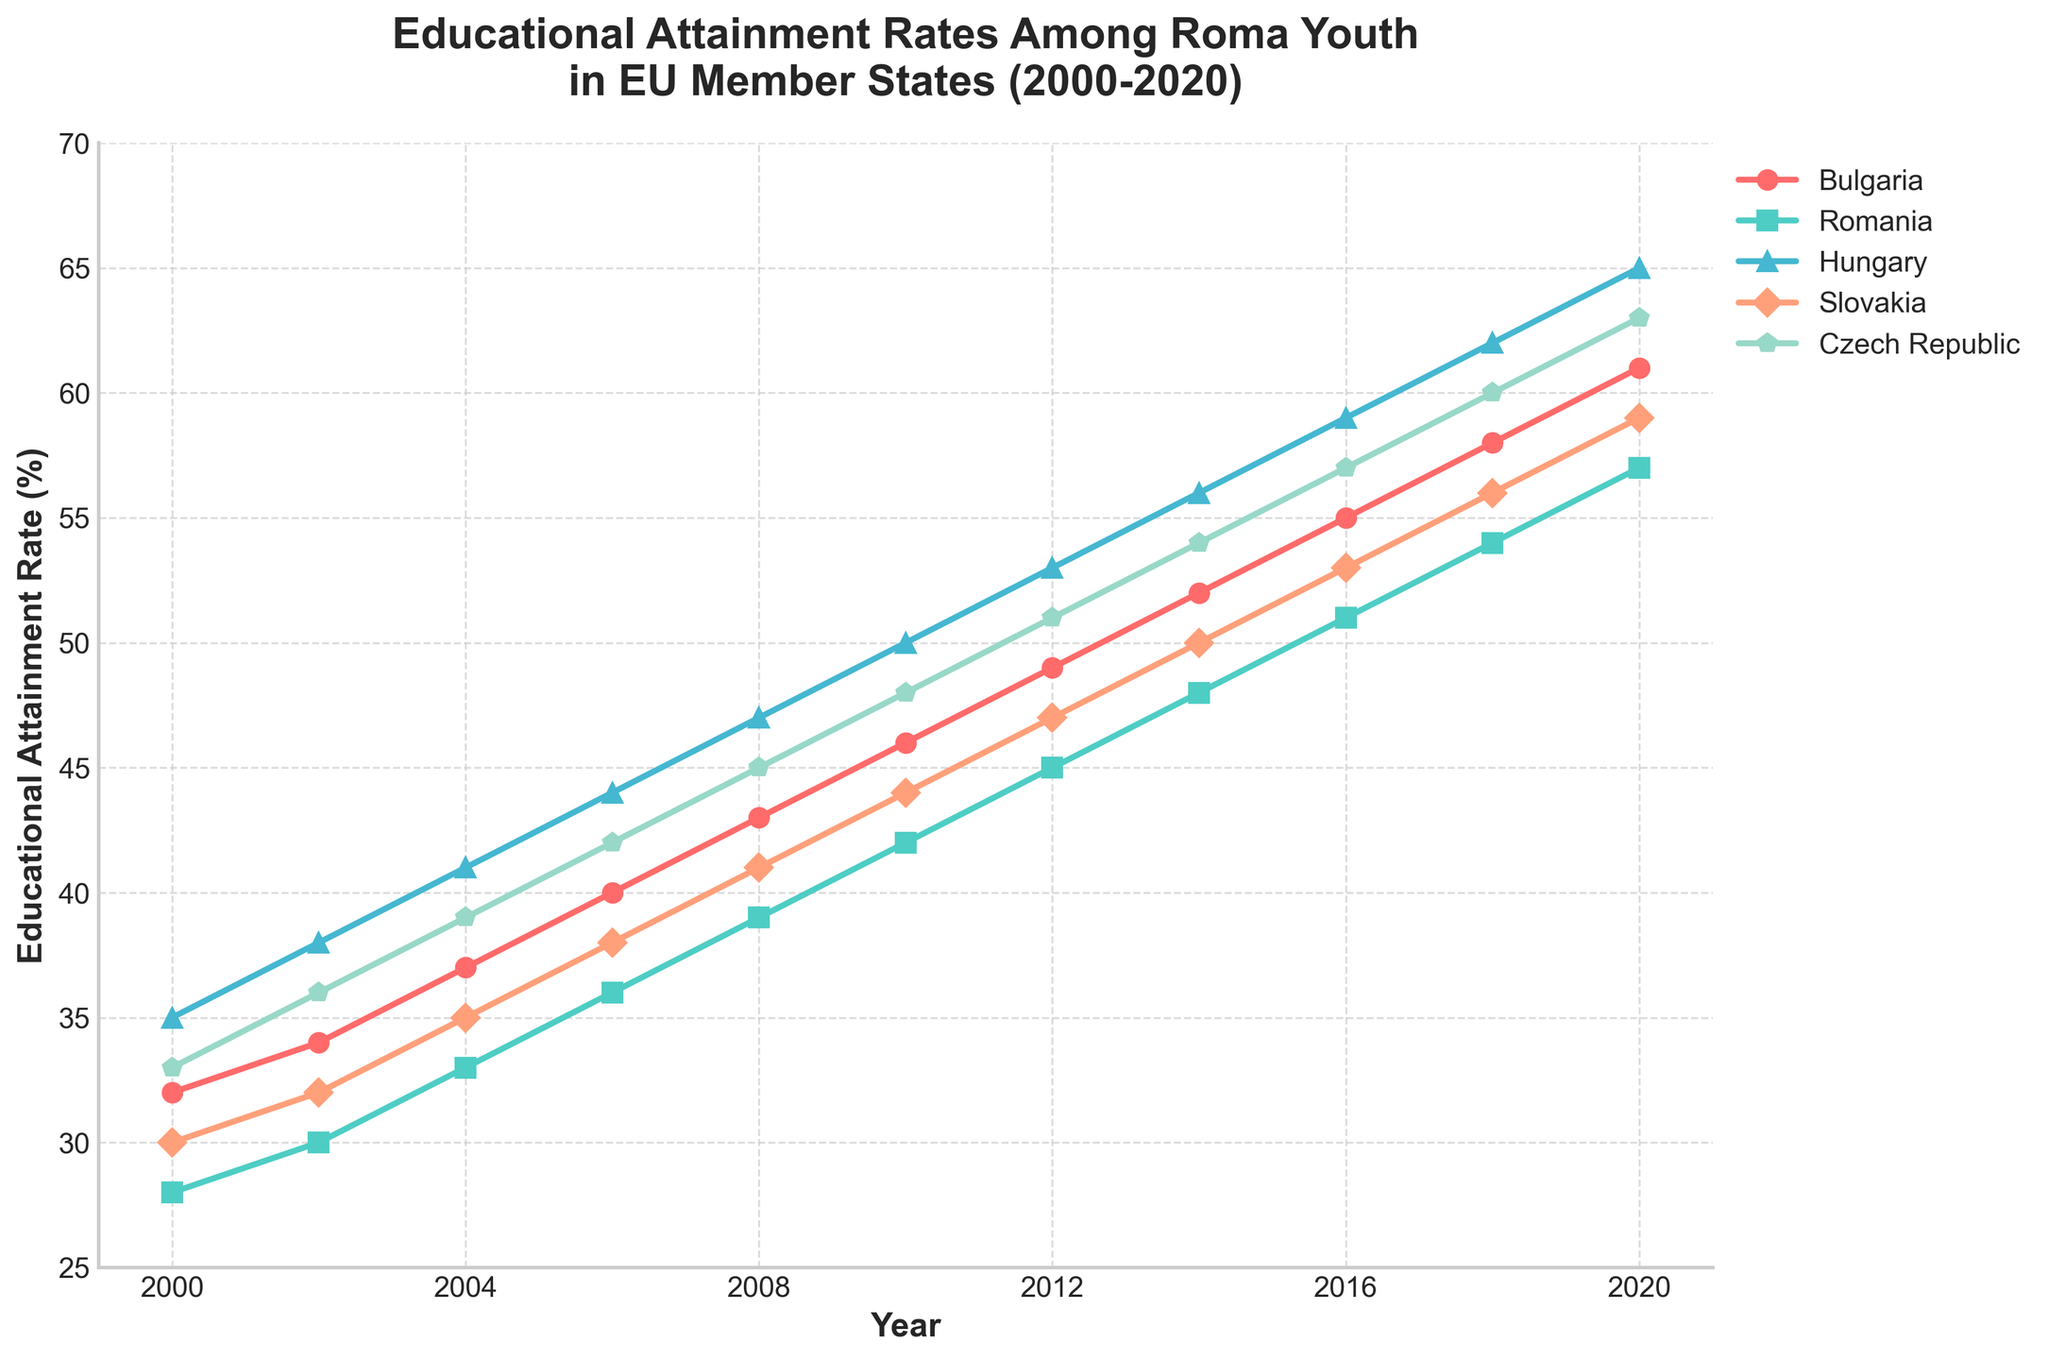What is the educational attainment rate for Roma youth in Bulgaria in 2020? The figure shows a line plot for each country from 2000 to 2020. Find the line corresponding to Bulgaria, and read the data point for the year 2020.
Answer: 61% Which country had the lowest educational attainment rate in 2004? Compare the data points of each line (representing each country) at the year 2004 and identify the one with the lowest value.
Answer: Romania From 2000 to 2020, which country showed the largest absolute increase in educational attainment rates among Roma youth? To find the largest absolute increase, calculate the difference in educational attainment rates between 2000 and 2020 for each country and compare these values. Bulgaria: 61-32=29, Romania: 57-28=29, Hungary: 65-35=30, Slovakia: 59-30=29, Czech Republic: 63-33=30.
Answer: Hungary and Czech Republic In which year did Romania's educational attainment rate surpass 50%? Follow the line corresponding to Romania and identify the first data point where the rate is above 50%.
Answer: 2016 Compare the educational attainment rates of Hungary and Slovakia in 2012. Which was higher and by how much? Locate the 2012 data points for Hungary and Slovakia and calculate the difference between these values. Hungary: 53, Slovakia: 47; 53-47=6.
Answer: Hungary, by 6% Which country had the most consistent increase in educational attainment rates over time? Examine the slope of each line (country) in the figure. The more consistently upward-sloping line indicates a more consistent increase. Bulgaria's and Hungary's lines are consistently upward, but Bulgaria has no fluctuations.
Answer: Bulgaria How much did the educational attainment rate in the Czech Republic change between 2000 and 2010? Locate the data points for the Czech Republic in 2000 and 2010, and subtract the 2000 value from the 2010 value. 48-33=15.
Answer: 15% What is the approximate average annual increase in educational attainment rates for Slovakia from 2000 to 2020? The average annual increase can be computed by dividing the total increase over the period by the number of years. (59-30)/(2020-2000)=29/20=1.45.
Answer: 1.45% In 2020, what is the difference in educational attainment rates between Bulgaria and Romania? Find the 2020 values for both Bulgaria and Romania, and calculate the difference. 61-57=4.
Answer: 4% Which country experienced the highest educational attainment rate in 2020, and what was the rate? Identify the highest data point among all countries in 2020.
Answer: Hungary, 65% 